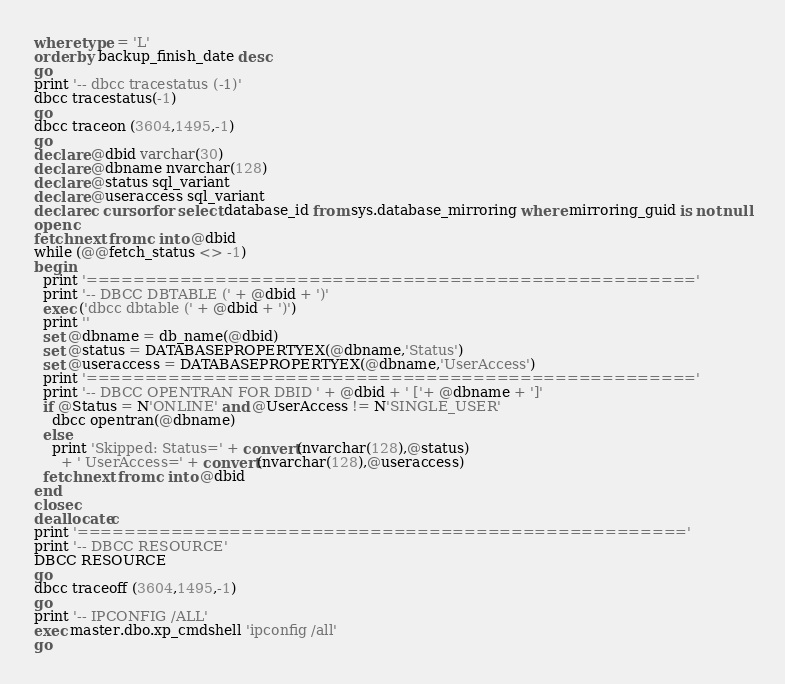<code> <loc_0><loc_0><loc_500><loc_500><_SQL_>where type = 'L' 
order by backup_finish_date desc
go
print '-- dbcc tracestatus (-1)'
dbcc tracestatus(-1)
go
dbcc traceon (3604,1495,-1)
go
declare @dbid varchar(30)
declare @dbname nvarchar(128)
declare @status sql_variant
declare @useraccess sql_variant
declare c cursor for select database_id from sys.database_mirroring where mirroring_guid is not null
open c
fetch next from c into @dbid
while (@@fetch_status <> -1)
begin
  print '===================================================='
  print '-- DBCC DBTABLE (' + @dbid + ')'
  exec ('dbcc dbtable (' + @dbid + ')')
  print ''
  set @dbname = db_name(@dbid)
  set @status = DATABASEPROPERTYEX(@dbname,'Status')
  set @useraccess = DATABASEPROPERTYEX(@dbname,'UserAccess')
  print '===================================================='
  print '-- DBCC OPENTRAN FOR DBID ' + @dbid + ' ['+ @dbname + ']'
  if @Status = N'ONLINE' and @UserAccess != N'SINGLE_USER'
    dbcc opentran(@dbname)
  else
    print 'Skipped: Status=' + convert(nvarchar(128),@status)
      + ' UserAccess=' + convert(nvarchar(128),@useraccess)
  fetch next from c into @dbid
end
close c
deallocate c
print '===================================================='
print '-- DBCC RESOURCE'
DBCC RESOURCE
go
dbcc traceoff (3604,1495,-1)
go
print '-- IPCONFIG /ALL'
exec master.dbo.xp_cmdshell 'ipconfig /all'
go
</code> 